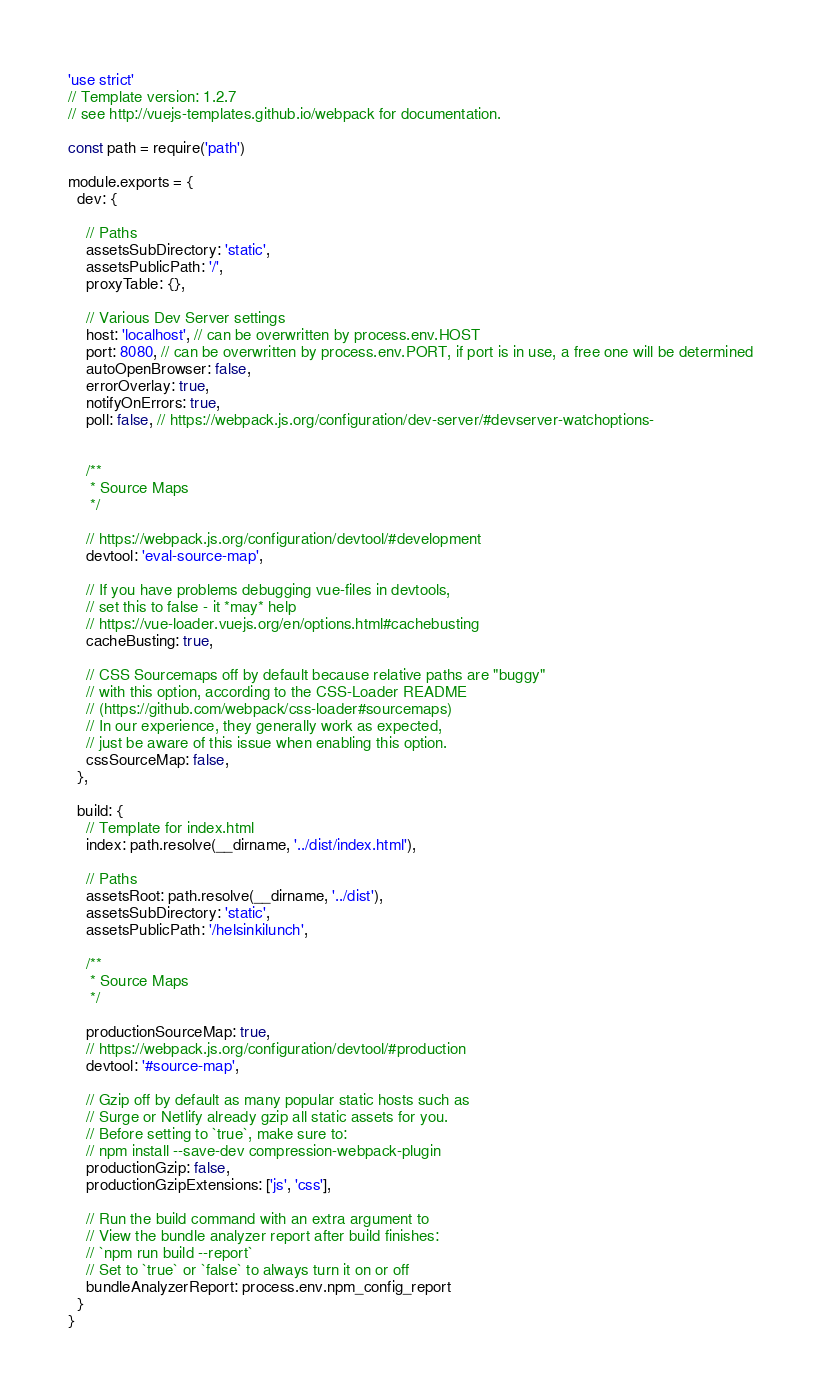<code> <loc_0><loc_0><loc_500><loc_500><_JavaScript_>'use strict'
// Template version: 1.2.7
// see http://vuejs-templates.github.io/webpack for documentation.

const path = require('path')

module.exports = {
  dev: {

    // Paths
    assetsSubDirectory: 'static',
    assetsPublicPath: '/',
    proxyTable: {},

    // Various Dev Server settings
    host: 'localhost', // can be overwritten by process.env.HOST
    port: 8080, // can be overwritten by process.env.PORT, if port is in use, a free one will be determined
    autoOpenBrowser: false,
    errorOverlay: true,
    notifyOnErrors: true,
    poll: false, // https://webpack.js.org/configuration/dev-server/#devserver-watchoptions-

    
    /**
     * Source Maps
     */

    // https://webpack.js.org/configuration/devtool/#development
    devtool: 'eval-source-map',

    // If you have problems debugging vue-files in devtools,
    // set this to false - it *may* help
    // https://vue-loader.vuejs.org/en/options.html#cachebusting
    cacheBusting: true,

    // CSS Sourcemaps off by default because relative paths are "buggy"
    // with this option, according to the CSS-Loader README
    // (https://github.com/webpack/css-loader#sourcemaps)
    // In our experience, they generally work as expected,
    // just be aware of this issue when enabling this option.
    cssSourceMap: false,
  },

  build: {
    // Template for index.html
    index: path.resolve(__dirname, '../dist/index.html'),

    // Paths
    assetsRoot: path.resolve(__dirname, '../dist'),
    assetsSubDirectory: 'static',
    assetsPublicPath: '/helsinkilunch',

    /**
     * Source Maps
     */

    productionSourceMap: true,
    // https://webpack.js.org/configuration/devtool/#production
    devtool: '#source-map',

    // Gzip off by default as many popular static hosts such as
    // Surge or Netlify already gzip all static assets for you.
    // Before setting to `true`, make sure to:
    // npm install --save-dev compression-webpack-plugin
    productionGzip: false,
    productionGzipExtensions: ['js', 'css'],

    // Run the build command with an extra argument to
    // View the bundle analyzer report after build finishes:
    // `npm run build --report`
    // Set to `true` or `false` to always turn it on or off
    bundleAnalyzerReport: process.env.npm_config_report
  }
}
</code> 